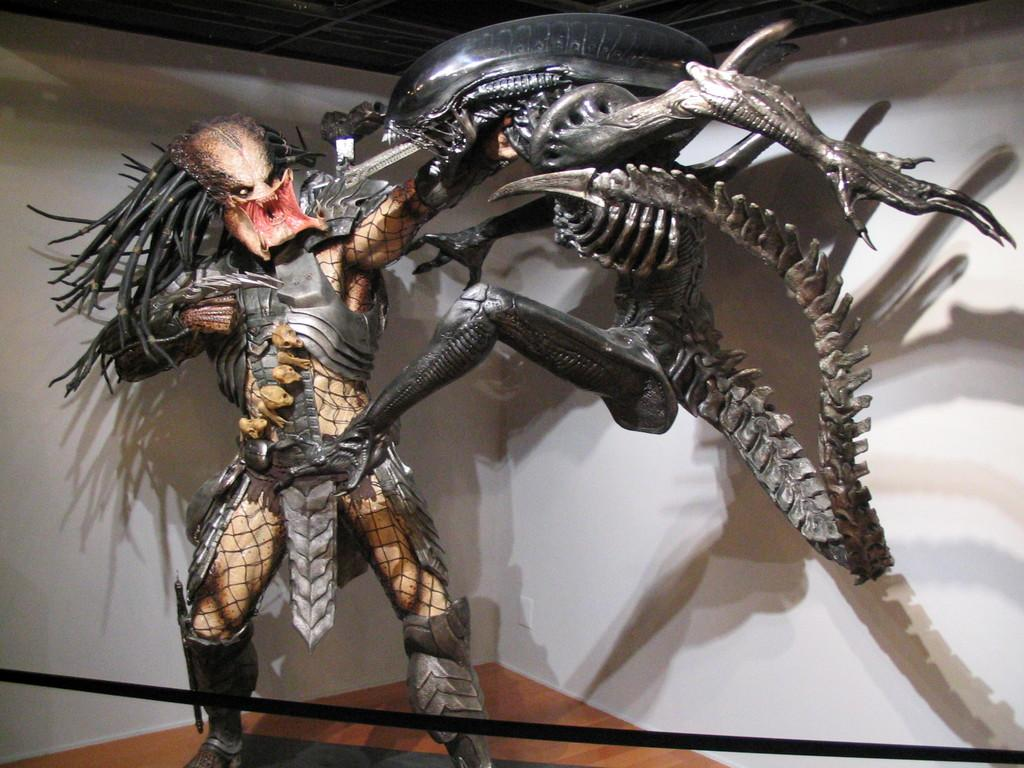What is the main subject in the image? There is a statue in the image. Can you describe the setting of the image? There is a wall in the background of the image. What type of pencil can be seen in the image? There is no pencil present in the image. 